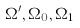Convert formula to latex. <formula><loc_0><loc_0><loc_500><loc_500>\Omega ^ { \prime } , \Omega _ { 0 } , \Omega _ { 1 }</formula> 